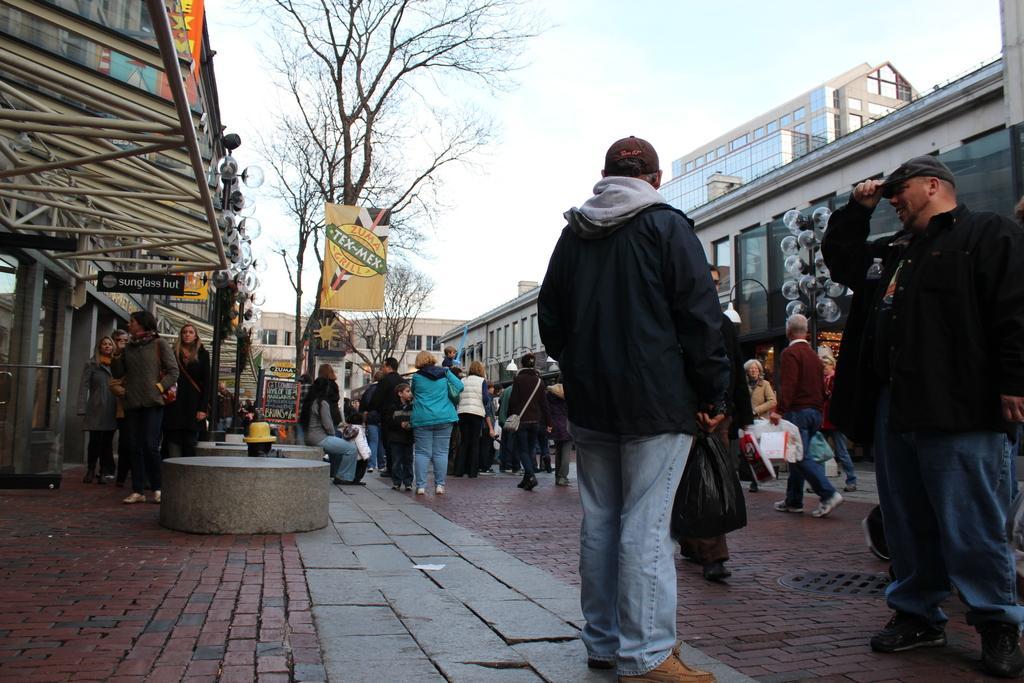Describe this image in one or two sentences. As we can see in the image there are group of people here and there, banner, trees, balloons, buildings and sky. 